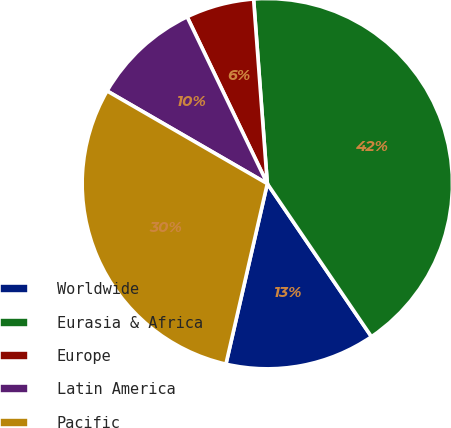<chart> <loc_0><loc_0><loc_500><loc_500><pie_chart><fcel>Worldwide<fcel>Eurasia & Africa<fcel>Europe<fcel>Latin America<fcel>Pacific<nl><fcel>13.1%<fcel>41.67%<fcel>5.95%<fcel>9.52%<fcel>29.76%<nl></chart> 